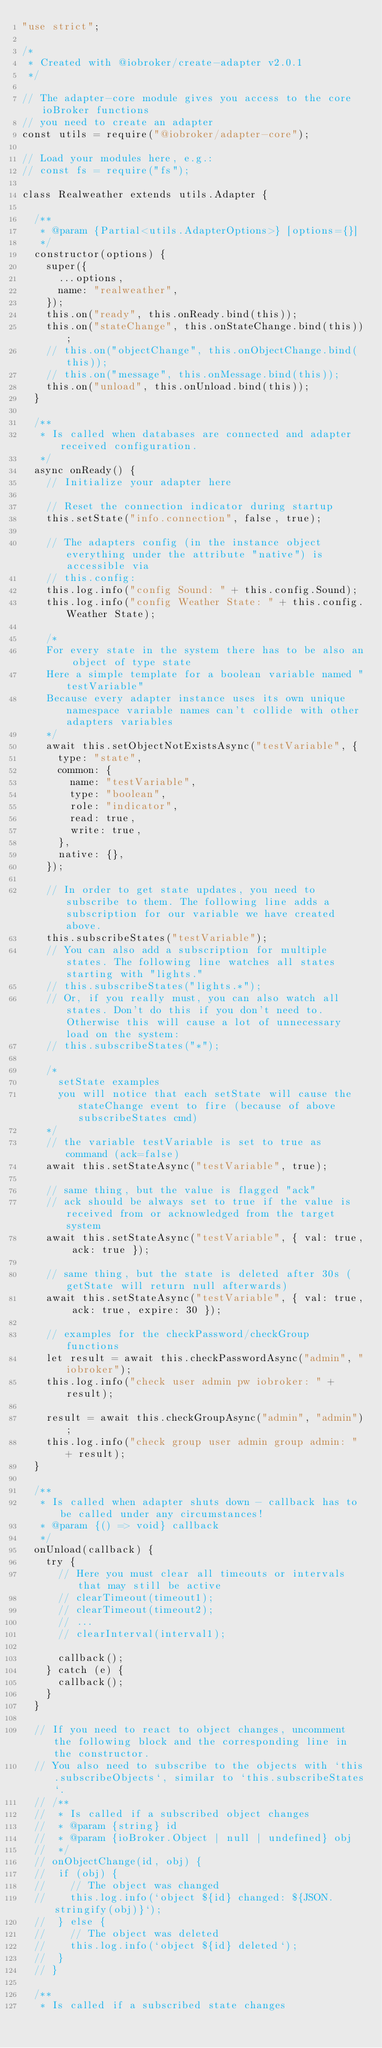<code> <loc_0><loc_0><loc_500><loc_500><_JavaScript_>"use strict";

/*
 * Created with @iobroker/create-adapter v2.0.1
 */

// The adapter-core module gives you access to the core ioBroker functions
// you need to create an adapter
const utils = require("@iobroker/adapter-core");

// Load your modules here, e.g.:
// const fs = require("fs");

class Realweather extends utils.Adapter {

	/**
	 * @param {Partial<utils.AdapterOptions>} [options={}]
	 */
	constructor(options) {
		super({
			...options,
			name: "realweather",
		});
		this.on("ready", this.onReady.bind(this));
		this.on("stateChange", this.onStateChange.bind(this));
		// this.on("objectChange", this.onObjectChange.bind(this));
		// this.on("message", this.onMessage.bind(this));
		this.on("unload", this.onUnload.bind(this));
	}

	/**
	 * Is called when databases are connected and adapter received configuration.
	 */
	async onReady() {
		// Initialize your adapter here

		// Reset the connection indicator during startup
		this.setState("info.connection", false, true);

		// The adapters config (in the instance object everything under the attribute "native") is accessible via
		// this.config:
		this.log.info("config Sound: " + this.config.Sound);
		this.log.info("config Weather State: " + this.config.Weather State);

		/*
		For every state in the system there has to be also an object of type state
		Here a simple template for a boolean variable named "testVariable"
		Because every adapter instance uses its own unique namespace variable names can't collide with other adapters variables
		*/
		await this.setObjectNotExistsAsync("testVariable", {
			type: "state",
			common: {
				name: "testVariable",
				type: "boolean",
				role: "indicator",
				read: true,
				write: true,
			},
			native: {},
		});

		// In order to get state updates, you need to subscribe to them. The following line adds a subscription for our variable we have created above.
		this.subscribeStates("testVariable");
		// You can also add a subscription for multiple states. The following line watches all states starting with "lights."
		// this.subscribeStates("lights.*");
		// Or, if you really must, you can also watch all states. Don't do this if you don't need to. Otherwise this will cause a lot of unnecessary load on the system:
		// this.subscribeStates("*");

		/*
			setState examples
			you will notice that each setState will cause the stateChange event to fire (because of above subscribeStates cmd)
		*/
		// the variable testVariable is set to true as command (ack=false)
		await this.setStateAsync("testVariable", true);

		// same thing, but the value is flagged "ack"
		// ack should be always set to true if the value is received from or acknowledged from the target system
		await this.setStateAsync("testVariable", { val: true, ack: true });

		// same thing, but the state is deleted after 30s (getState will return null afterwards)
		await this.setStateAsync("testVariable", { val: true, ack: true, expire: 30 });

		// examples for the checkPassword/checkGroup functions
		let result = await this.checkPasswordAsync("admin", "iobroker");
		this.log.info("check user admin pw iobroker: " + result);

		result = await this.checkGroupAsync("admin", "admin");
		this.log.info("check group user admin group admin: " + result);
	}

	/**
	 * Is called when adapter shuts down - callback has to be called under any circumstances!
	 * @param {() => void} callback
	 */
	onUnload(callback) {
		try {
			// Here you must clear all timeouts or intervals that may still be active
			// clearTimeout(timeout1);
			// clearTimeout(timeout2);
			// ...
			// clearInterval(interval1);

			callback();
		} catch (e) {
			callback();
		}
	}

	// If you need to react to object changes, uncomment the following block and the corresponding line in the constructor.
	// You also need to subscribe to the objects with `this.subscribeObjects`, similar to `this.subscribeStates`.
	// /**
	//  * Is called if a subscribed object changes
	//  * @param {string} id
	//  * @param {ioBroker.Object | null | undefined} obj
	//  */
	// onObjectChange(id, obj) {
	// 	if (obj) {
	// 		// The object was changed
	// 		this.log.info(`object ${id} changed: ${JSON.stringify(obj)}`);
	// 	} else {
	// 		// The object was deleted
	// 		this.log.info(`object ${id} deleted`);
	// 	}
	// }

	/**
	 * Is called if a subscribed state changes</code> 